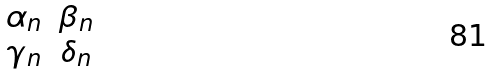<formula> <loc_0><loc_0><loc_500><loc_500>\begin{matrix} \alpha _ { n } & \beta _ { n } \\ \gamma _ { n } & \delta _ { n } \end{matrix}</formula> 